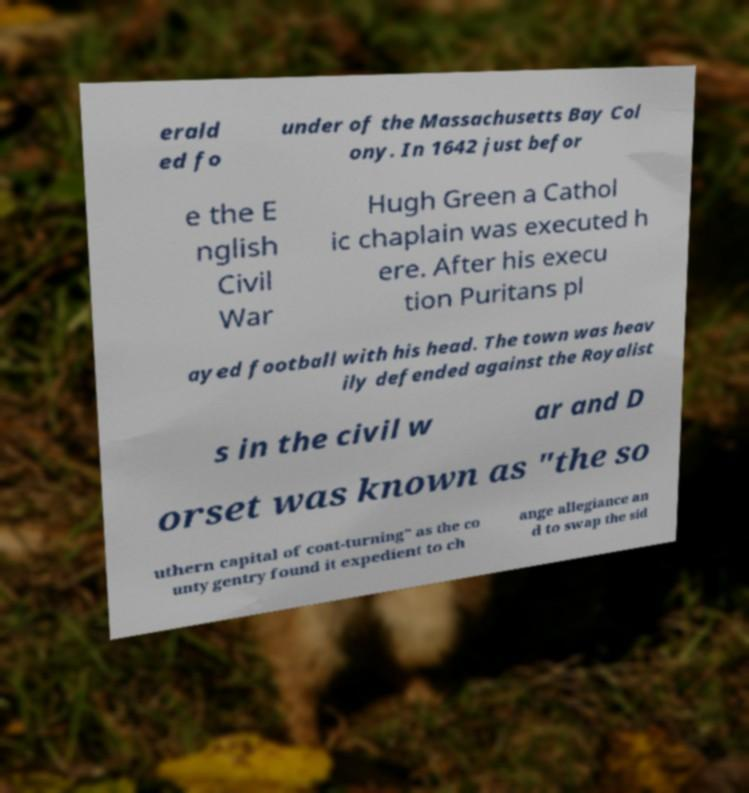For documentation purposes, I need the text within this image transcribed. Could you provide that? erald ed fo under of the Massachusetts Bay Col ony. In 1642 just befor e the E nglish Civil War Hugh Green a Cathol ic chaplain was executed h ere. After his execu tion Puritans pl ayed football with his head. The town was heav ily defended against the Royalist s in the civil w ar and D orset was known as "the so uthern capital of coat-turning" as the co unty gentry found it expedient to ch ange allegiance an d to swap the sid 